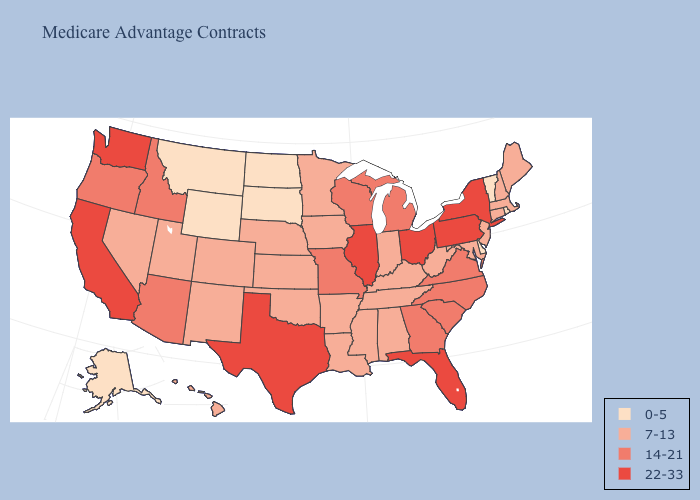Does South Dakota have the lowest value in the MidWest?
Keep it brief. Yes. What is the highest value in the South ?
Short answer required. 22-33. Name the states that have a value in the range 22-33?
Write a very short answer. California, Florida, Illinois, New York, Ohio, Pennsylvania, Texas, Washington. Among the states that border Utah , which have the lowest value?
Be succinct. Wyoming. Name the states that have a value in the range 0-5?
Concise answer only. Alaska, Delaware, Montana, North Dakota, Rhode Island, South Dakota, Vermont, Wyoming. Which states have the highest value in the USA?
Concise answer only. California, Florida, Illinois, New York, Ohio, Pennsylvania, Texas, Washington. What is the highest value in states that border Oregon?
Give a very brief answer. 22-33. What is the lowest value in the USA?
Concise answer only. 0-5. Name the states that have a value in the range 0-5?
Concise answer only. Alaska, Delaware, Montana, North Dakota, Rhode Island, South Dakota, Vermont, Wyoming. Name the states that have a value in the range 7-13?
Short answer required. Alabama, Arkansas, Colorado, Connecticut, Hawaii, Indiana, Iowa, Kansas, Kentucky, Louisiana, Maine, Maryland, Massachusetts, Minnesota, Mississippi, Nebraska, Nevada, New Hampshire, New Jersey, New Mexico, Oklahoma, Tennessee, Utah, West Virginia. Name the states that have a value in the range 22-33?
Keep it brief. California, Florida, Illinois, New York, Ohio, Pennsylvania, Texas, Washington. Which states have the lowest value in the USA?
Concise answer only. Alaska, Delaware, Montana, North Dakota, Rhode Island, South Dakota, Vermont, Wyoming. What is the value of Oregon?
Keep it brief. 14-21. Which states have the lowest value in the Northeast?
Keep it brief. Rhode Island, Vermont. What is the value of Michigan?
Keep it brief. 14-21. 